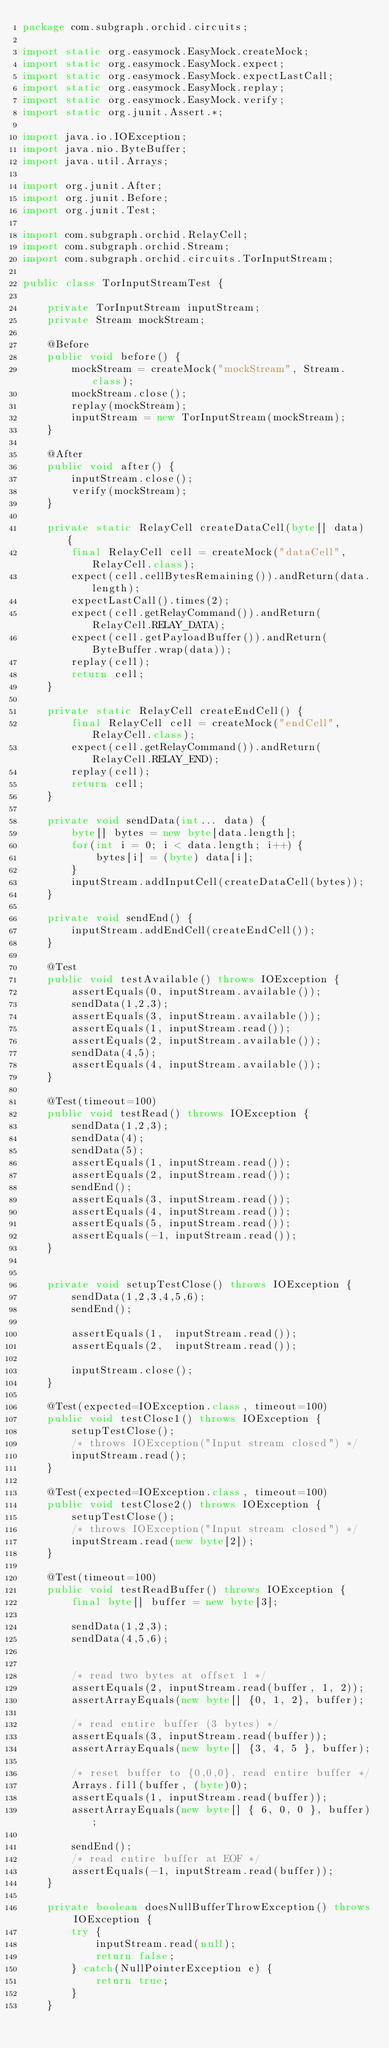<code> <loc_0><loc_0><loc_500><loc_500><_Java_>package com.subgraph.orchid.circuits;

import static org.easymock.EasyMock.createMock;
import static org.easymock.EasyMock.expect;
import static org.easymock.EasyMock.expectLastCall;
import static org.easymock.EasyMock.replay;
import static org.easymock.EasyMock.verify;
import static org.junit.Assert.*;

import java.io.IOException;
import java.nio.ByteBuffer;
import java.util.Arrays;

import org.junit.After;
import org.junit.Before;
import org.junit.Test;

import com.subgraph.orchid.RelayCell;
import com.subgraph.orchid.Stream;
import com.subgraph.orchid.circuits.TorInputStream;

public class TorInputStreamTest {

	private TorInputStream inputStream;
	private Stream mockStream;
	
	@Before
	public void before() {
		mockStream = createMock("mockStream", Stream.class);
		mockStream.close();
		replay(mockStream);
		inputStream = new TorInputStream(mockStream);
	}
	
	@After
	public void after() {
		inputStream.close();
		verify(mockStream);
	}
	
	private static RelayCell createDataCell(byte[] data) {
		final RelayCell cell = createMock("dataCell", RelayCell.class);
		expect(cell.cellBytesRemaining()).andReturn(data.length);
		expectLastCall().times(2);
		expect(cell.getRelayCommand()).andReturn(RelayCell.RELAY_DATA);
		expect(cell.getPayloadBuffer()).andReturn(ByteBuffer.wrap(data));
		replay(cell);
		return cell;
	}
	
	private static RelayCell createEndCell() {
		final RelayCell cell = createMock("endCell", RelayCell.class);
		expect(cell.getRelayCommand()).andReturn(RelayCell.RELAY_END);
		replay(cell);
		return cell;
	}
	
	private void sendData(int... data) {
		byte[] bytes = new byte[data.length];
		for(int i = 0; i < data.length; i++) {
			bytes[i] = (byte) data[i];
		}
		inputStream.addInputCell(createDataCell(bytes));
	}
	
	private void sendEnd() {
		inputStream.addEndCell(createEndCell());
	}
	
	@Test
	public void testAvailable() throws IOException {
		assertEquals(0, inputStream.available());
		sendData(1,2,3);
		assertEquals(3, inputStream.available());
		assertEquals(1, inputStream.read());
		assertEquals(2, inputStream.available());
		sendData(4,5);
		assertEquals(4, inputStream.available());
	}
	
	@Test(timeout=100)
	public void testRead() throws IOException {
		sendData(1,2,3);
		sendData(4);
		sendData(5);
		assertEquals(1, inputStream.read());
		assertEquals(2, inputStream.read());
		sendEnd();
		assertEquals(3, inputStream.read());
		assertEquals(4, inputStream.read());
		assertEquals(5, inputStream.read());
		assertEquals(-1, inputStream.read());
	}
	
	
	private void setupTestClose() throws IOException {
		sendData(1,2,3,4,5,6);
		sendEnd();
		
		assertEquals(1,  inputStream.read());
		assertEquals(2,  inputStream.read());
		
		inputStream.close();
	}
	
	@Test(expected=IOException.class, timeout=100)
	public void testClose1() throws IOException {
		setupTestClose();
		/* throws IOException("Input stream closed") */
		inputStream.read();
	}
	
	@Test(expected=IOException.class, timeout=100)
	public void testClose2() throws IOException {
		setupTestClose();
		/* throws IOException("Input stream closed") */
		inputStream.read(new byte[2]);
	}
	
	@Test(timeout=100)
	public void testReadBuffer() throws IOException {
		final byte[] buffer = new byte[3];
		
		sendData(1,2,3);
		sendData(4,5,6);


		/* read two bytes at offset 1 */
		assertEquals(2, inputStream.read(buffer, 1, 2));
		assertArrayEquals(new byte[] {0, 1, 2}, buffer);
		
		/* read entire buffer (3 bytes) */
		assertEquals(3, inputStream.read(buffer));
		assertArrayEquals(new byte[] {3, 4, 5 }, buffer);
		
		/* reset buffer to {0,0,0}, read entire buffer */
		Arrays.fill(buffer, (byte)0);
		assertEquals(1, inputStream.read(buffer));
		assertArrayEquals(new byte[] { 6, 0, 0 }, buffer);

		sendEnd();
		/* read entire buffer at EOF */
		assertEquals(-1, inputStream.read(buffer));
	}
	
	private boolean doesNullBufferThrowException() throws IOException {
		try {
			inputStream.read(null);
			return false;
		} catch(NullPointerException e) {
			return true;
		}
	}
	</code> 